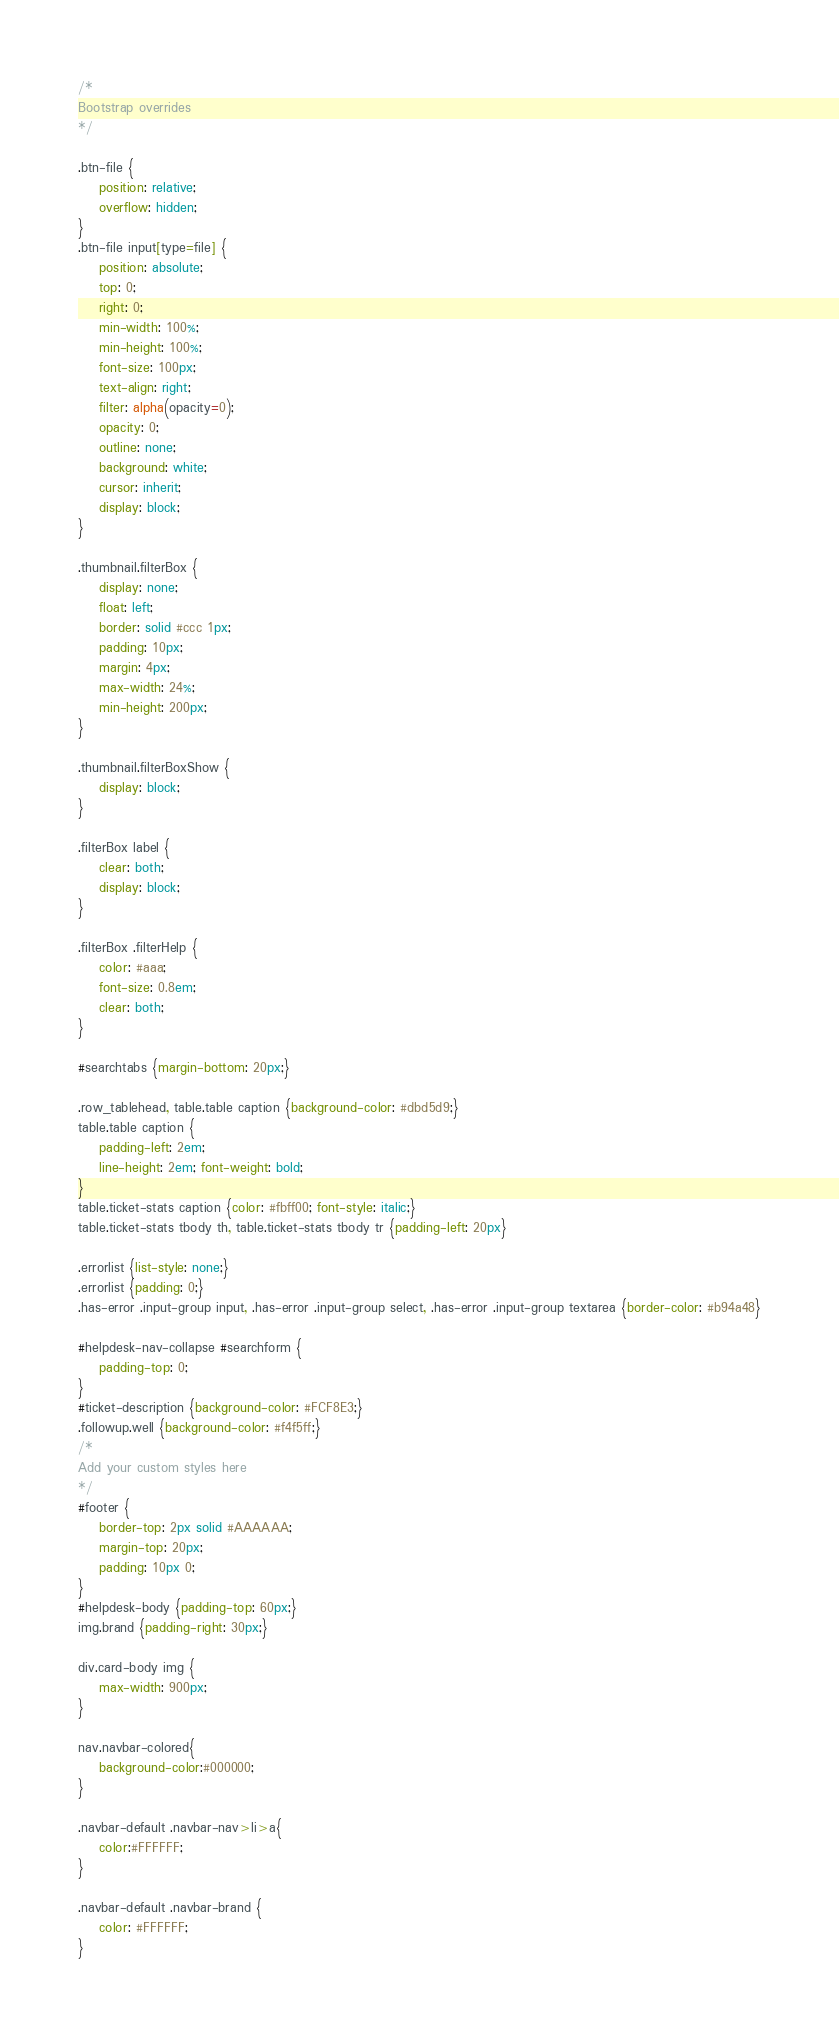Convert code to text. <code><loc_0><loc_0><loc_500><loc_500><_CSS_>/*
Bootstrap overrides
*/

.btn-file {
    position: relative;
    overflow: hidden;
}
.btn-file input[type=file] {
    position: absolute;
    top: 0;
    right: 0;
    min-width: 100%;
    min-height: 100%;
    font-size: 100px;
    text-align: right;
    filter: alpha(opacity=0);
    opacity: 0;
    outline: none;
    background: white;
    cursor: inherit;
    display: block;
}

.thumbnail.filterBox {
    display: none;
    float: left;
    border: solid #ccc 1px;
    padding: 10px;
    margin: 4px;
    max-width: 24%;
    min-height: 200px;
}

.thumbnail.filterBoxShow {
    display: block;
}

.filterBox label {
    clear: both;
    display: block;
}

.filterBox .filterHelp {
    color: #aaa;
    font-size: 0.8em;
    clear: both;
}

#searchtabs {margin-bottom: 20px;}

.row_tablehead, table.table caption {background-color: #dbd5d9;}
table.table caption {
    padding-left: 2em; 
    line-height: 2em; font-weight: bold;
}
table.ticket-stats caption {color: #fbff00; font-style: italic;}
table.ticket-stats tbody th, table.ticket-stats tbody tr {padding-left: 20px}

.errorlist {list-style: none;}
.errorlist {padding: 0;}
.has-error .input-group input, .has-error .input-group select, .has-error .input-group textarea {border-color: #b94a48}

#helpdesk-nav-collapse #searchform {
    padding-top: 0;
}
#ticket-description {background-color: #FCF8E3;}
.followup.well {background-color: #f4f5ff;}
/*
Add your custom styles here
*/
#footer {
    border-top: 2px solid #AAAAAA;
    margin-top: 20px;
    padding: 10px 0;
}
#helpdesk-body {padding-top: 60px;}
img.brand {padding-right: 30px;}

div.card-body img {
	max-width: 900px;
}

nav.navbar-colored{
    background-color:#000000;
}

.navbar-default .navbar-nav>li>a{    
    color:#FFFFFF;
}

.navbar-default .navbar-brand {
    color: #FFFFFF;
}
</code> 